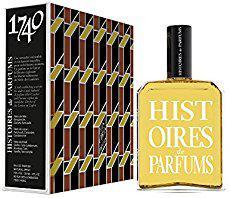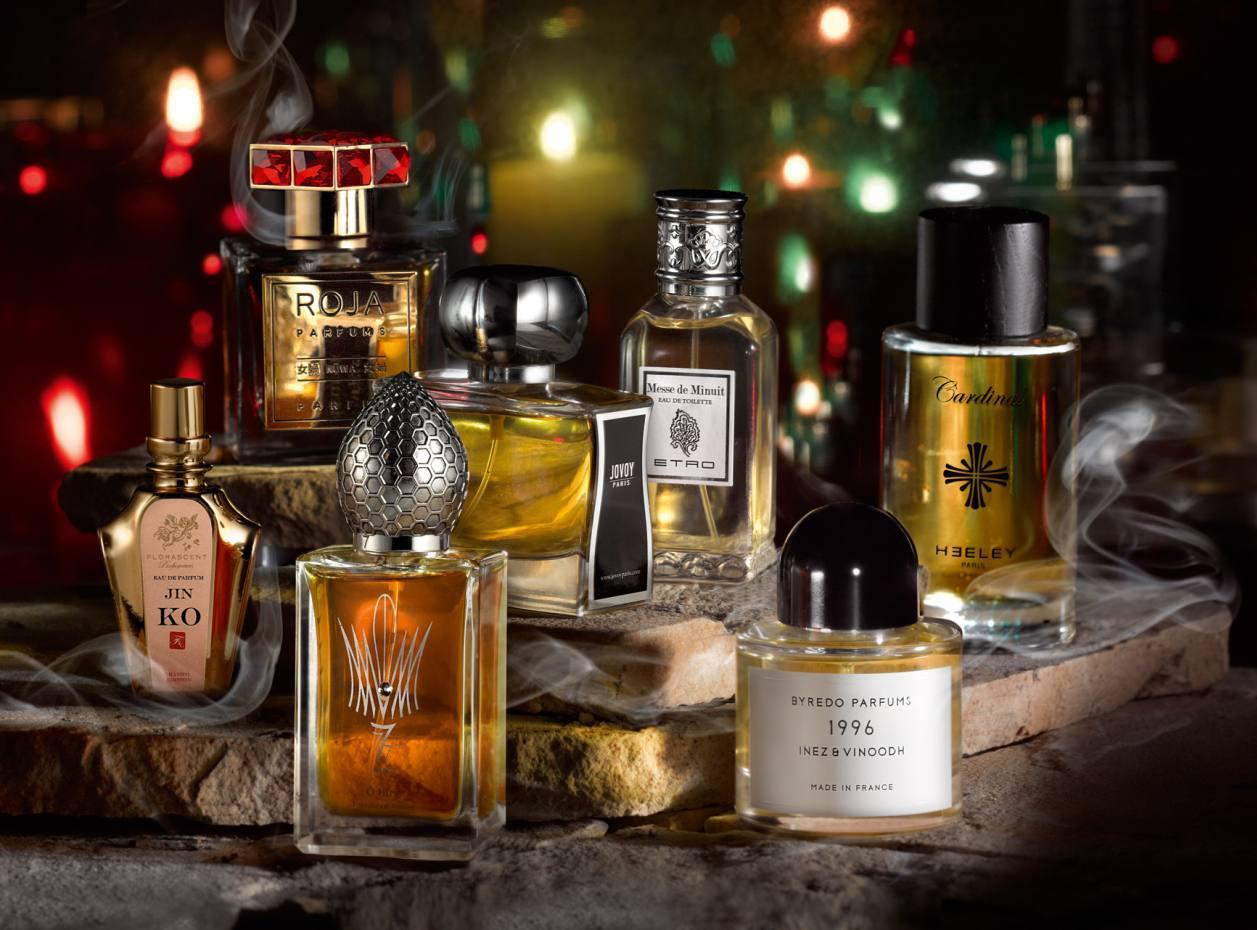The first image is the image on the left, the second image is the image on the right. Evaluate the accuracy of this statement regarding the images: "One image shows a single squarish bottle to the right of its upright case.". Is it true? Answer yes or no. Yes. The first image is the image on the left, the second image is the image on the right. Examine the images to the left and right. Is the description "One of the images shows a single bottle of perfume standing next to its package." accurate? Answer yes or no. Yes. 